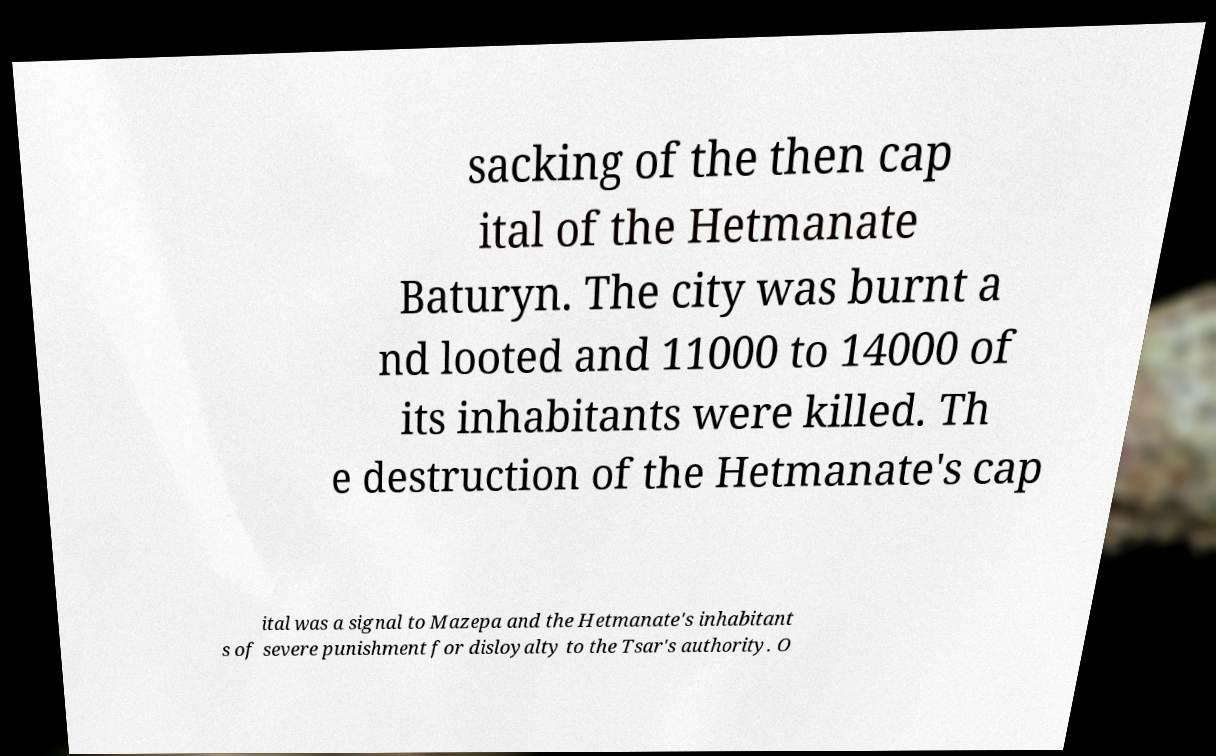Can you read and provide the text displayed in the image?This photo seems to have some interesting text. Can you extract and type it out for me? sacking of the then cap ital of the Hetmanate Baturyn. The city was burnt a nd looted and 11000 to 14000 of its inhabitants were killed. Th e destruction of the Hetmanate's cap ital was a signal to Mazepa and the Hetmanate's inhabitant s of severe punishment for disloyalty to the Tsar's authority. O 